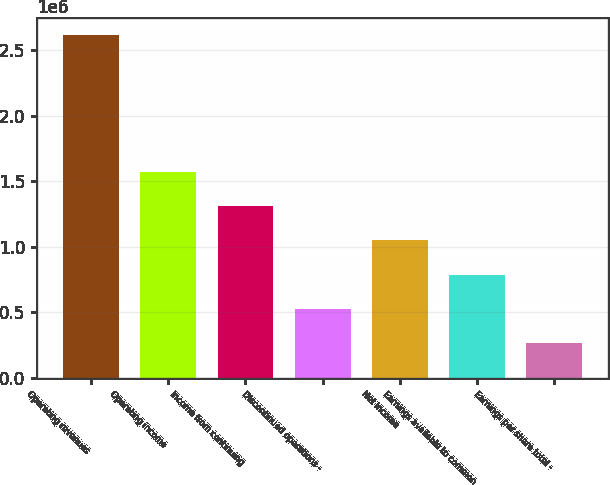<chart> <loc_0><loc_0><loc_500><loc_500><bar_chart><fcel>Operating revenues<fcel>Operating income<fcel>Income from continuing<fcel>Discontinued operations -<fcel>Net income<fcel>Earnings available to common<fcel>Earnings per share total -<nl><fcel>2.61812e+06<fcel>1.57087e+06<fcel>1.30906e+06<fcel>523623<fcel>1.04725e+06<fcel>785435<fcel>261812<nl></chart> 